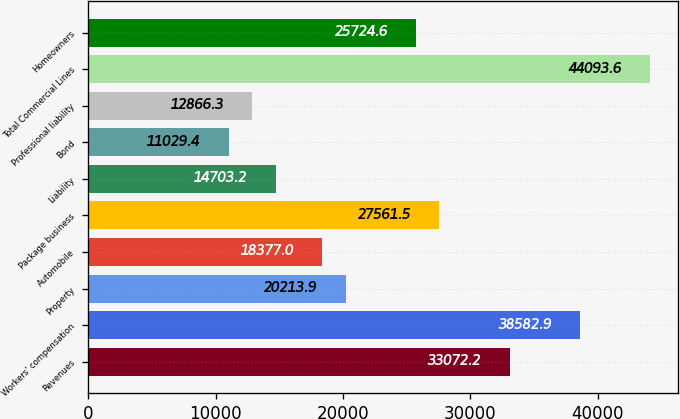<chart> <loc_0><loc_0><loc_500><loc_500><bar_chart><fcel>Revenues<fcel>Workers' compensation<fcel>Property<fcel>Automobile<fcel>Package business<fcel>Liability<fcel>Bond<fcel>Professional liability<fcel>Total Commercial Lines<fcel>Homeowners<nl><fcel>33072.2<fcel>38582.9<fcel>20213.9<fcel>18377<fcel>27561.5<fcel>14703.2<fcel>11029.4<fcel>12866.3<fcel>44093.6<fcel>25724.6<nl></chart> 